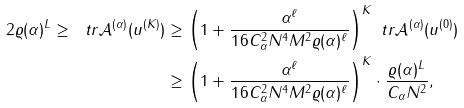Convert formula to latex. <formula><loc_0><loc_0><loc_500><loc_500>2 \varrho ( \alpha ) ^ { L } \geq \ t r \mathcal { A } ^ { ( \alpha ) } ( u ^ { ( K ) } ) & \geq \left ( 1 + \frac { \alpha ^ { \ell } } { 1 6 C _ { \alpha } ^ { 2 } N ^ { 4 } M ^ { 2 } \varrho ( \alpha ) ^ { \ell } } \right ) ^ { K } \ t r \mathcal { A } ^ { ( \alpha ) } ( u ^ { ( 0 ) } ) \\ & \geq \left ( 1 + \frac { \alpha ^ { \ell } } { 1 6 C _ { \alpha } ^ { 2 } N ^ { 4 } M ^ { 2 } \varrho ( \alpha ) ^ { \ell } } \right ) ^ { K } \cdot \frac { \varrho ( \alpha ) ^ { L } } { C _ { \alpha } N ^ { 2 } } ,</formula> 